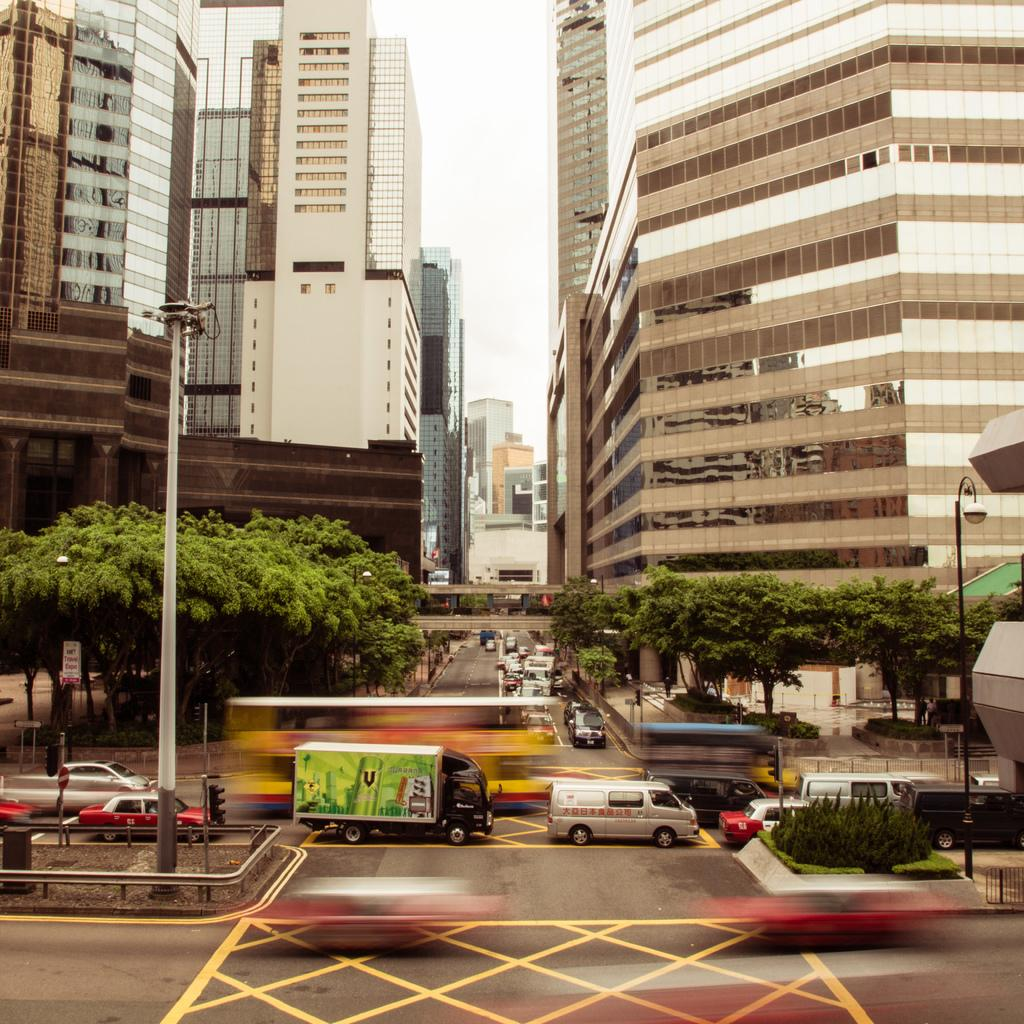What can be seen on the road in the image? There are vehicles on the road in the image. What structures are present in the image? There are poles, lights, trees, and buildings in the image. What is visible in the background of the image? The sky is visible in the background of the image. What type of roof can be seen on the vehicles in the image? There are no roofs visible on the vehicles in the image, as the focus is on the vehicles themselves and not their individual components. What thoughts are the trees having in the image? Trees do not have thoughts, as they are inanimate objects. 